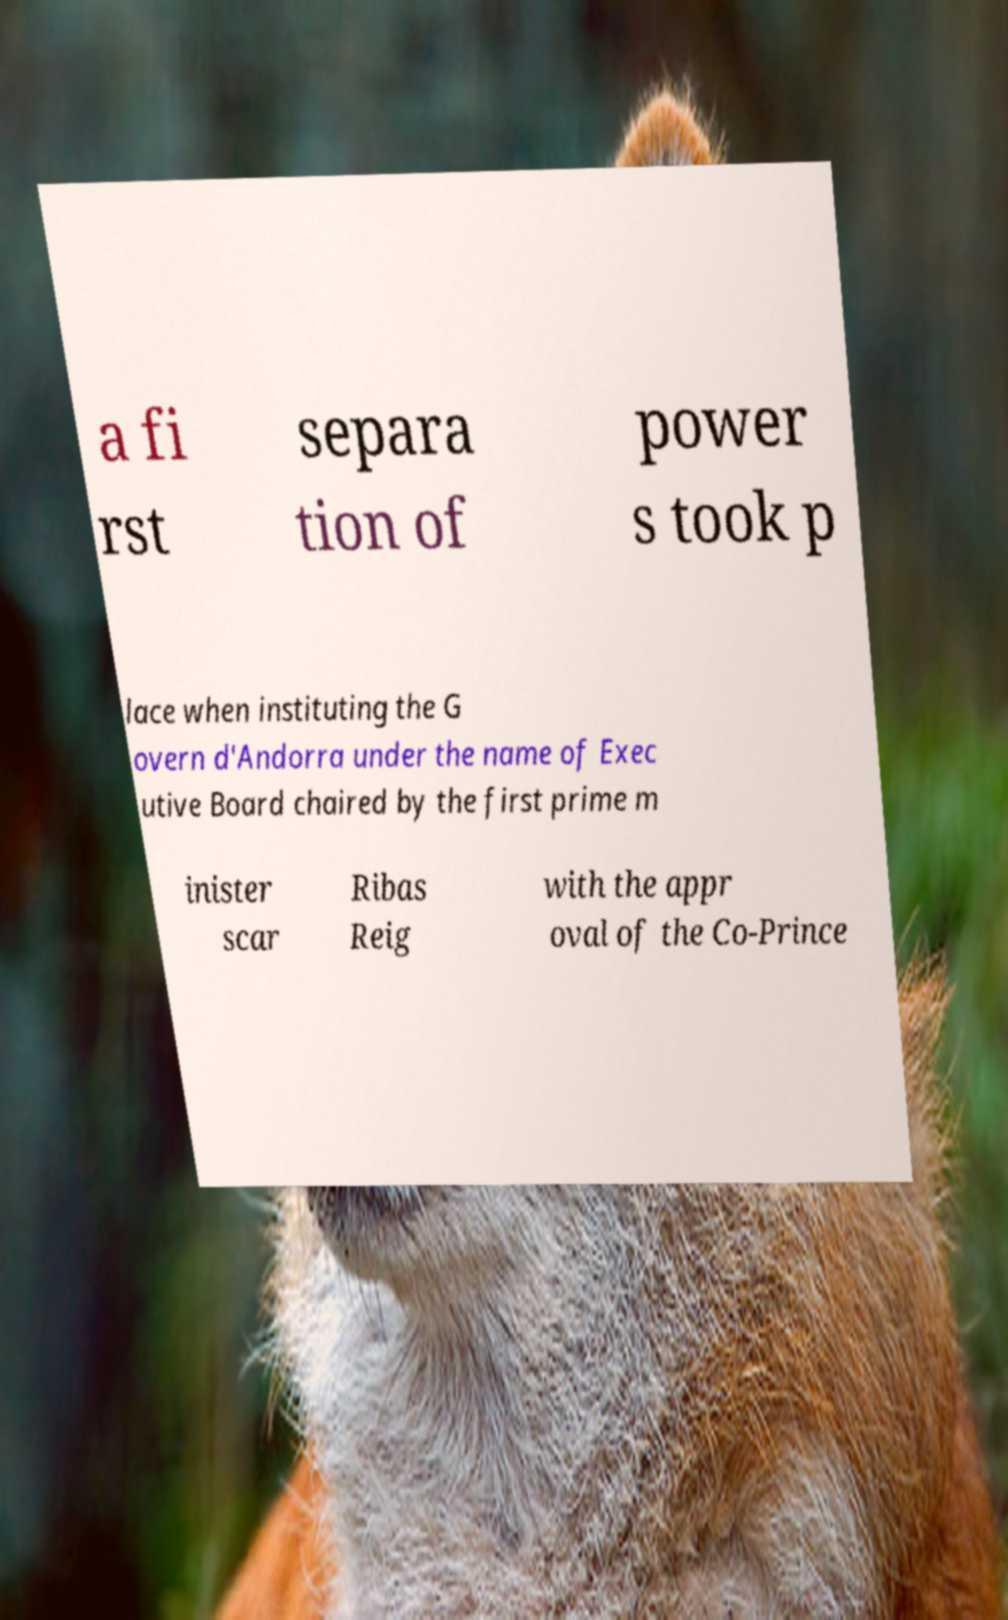What messages or text are displayed in this image? I need them in a readable, typed format. a fi rst separa tion of power s took p lace when instituting the G overn d'Andorra under the name of Exec utive Board chaired by the first prime m inister scar Ribas Reig with the appr oval of the Co-Prince 